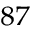<formula> <loc_0><loc_0><loc_500><loc_500>^ { 8 7 }</formula> 